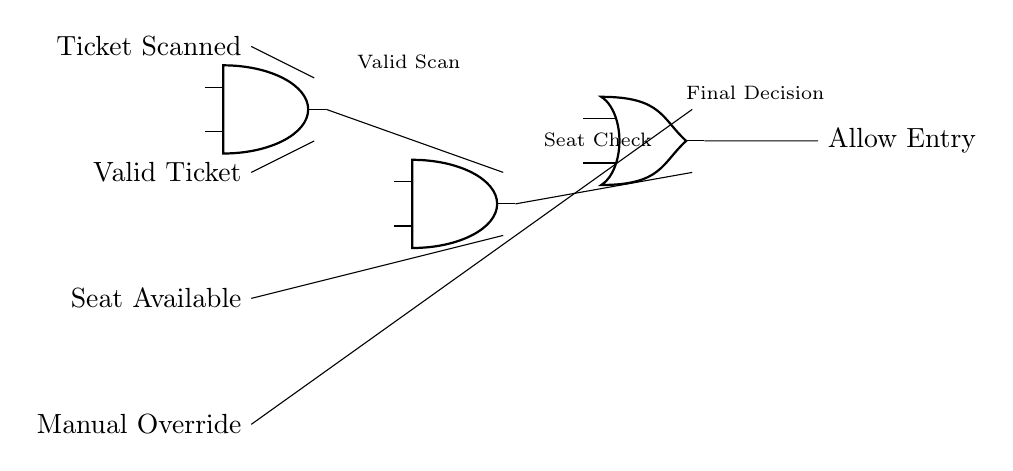What is the output of the AND gate labeled "ticketAND"? The output of the AND gate "ticketAND" is high (1) only if both input signals "Ticket Scanned" and "Valid Ticket" are high (1). If either input is low (0), the output will also be low (0).
Answer: output is high (1) How many inputs does the OR gate have? The OR gate, labeled as "finalOR," has two inputs: one from the output of the "seatAND" AND gate and the other from the "Manual Override" input.
Answer: two inputs What operation does the AND gate labeled "seatAND" perform before allowing entry? The AND gate "seatAND" performs a logical AND operation, meaning it produces an output high (1) only if both its inputs are true, which consists of the output from the "ticketAND" AND gate and the "Seat Available" input.
Answer: AND operation What is the purpose of the "Manual Override" in this circuit? The "Manual Override" allows for entry to be granted regardless of the logic gates' outputs, providing a fail-safe mechanism in case of any issues with the automatic checks.
Answer: fail-safe mechanism Which logic gate is used for the final decision on entry? The final decision on entry is made using an OR gate. It determines if the entry should be allowed based on its inputs.
Answer: OR gate 